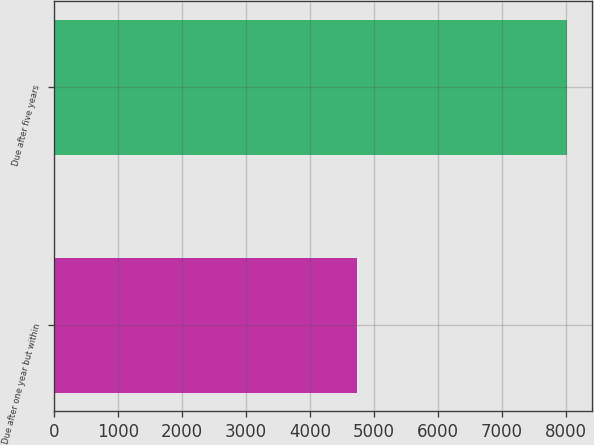Convert chart to OTSL. <chart><loc_0><loc_0><loc_500><loc_500><bar_chart><fcel>Due after one year but within<fcel>Due after five years<nl><fcel>4734<fcel>8014<nl></chart> 